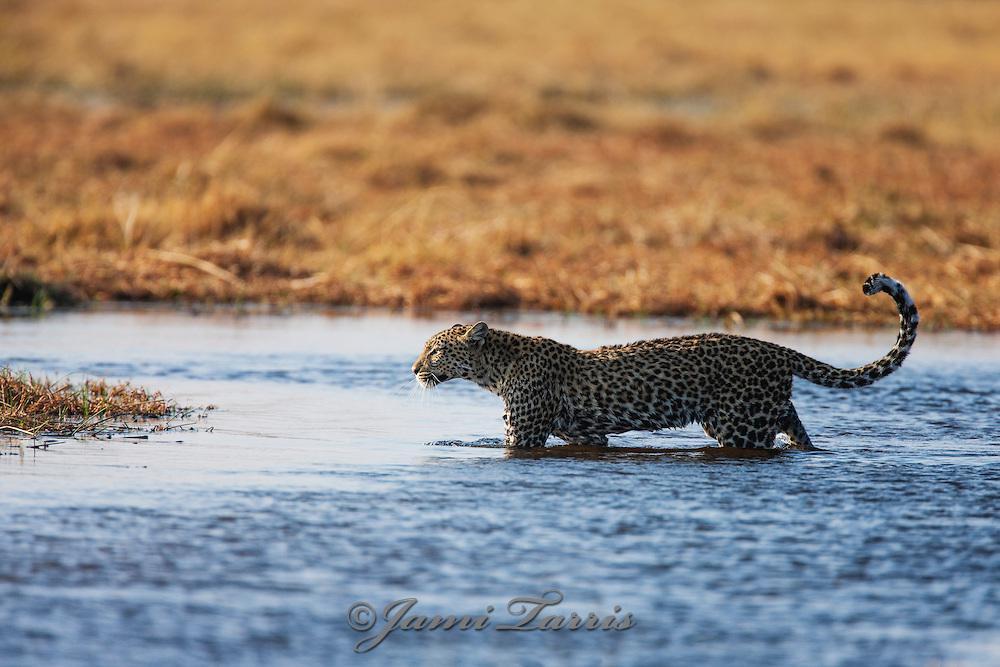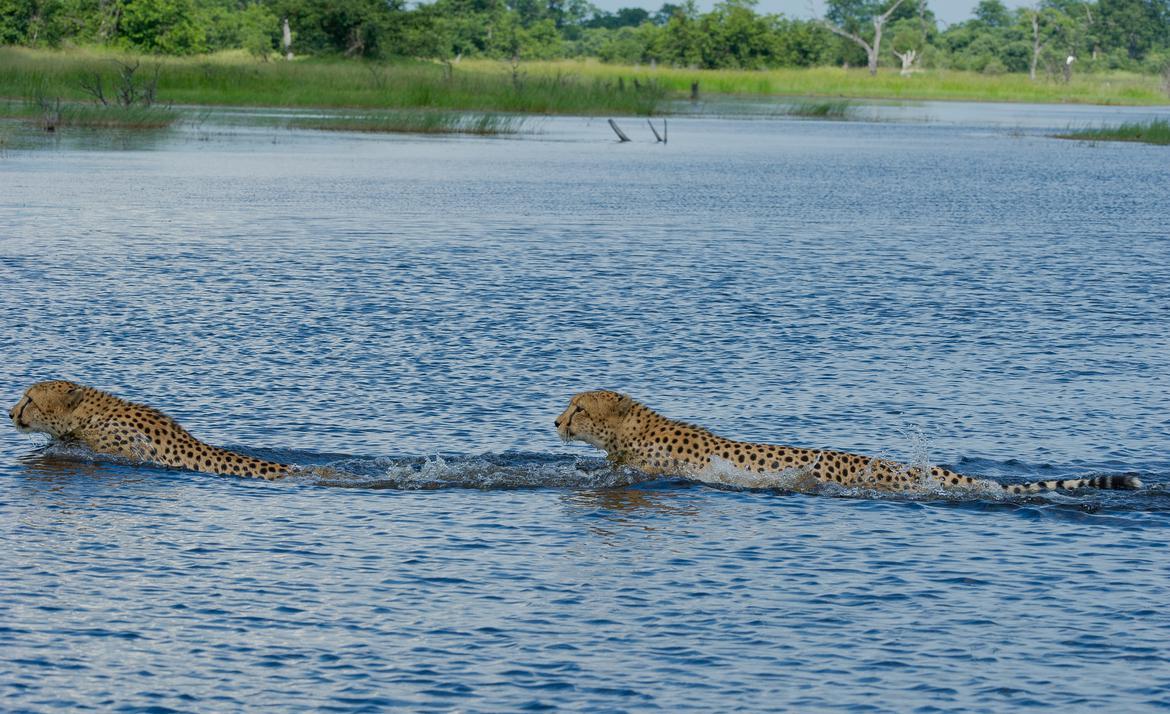The first image is the image on the left, the second image is the image on the right. Considering the images on both sides, is "The left image has a cheetah that is approaching the shore." valid? Answer yes or no. Yes. 